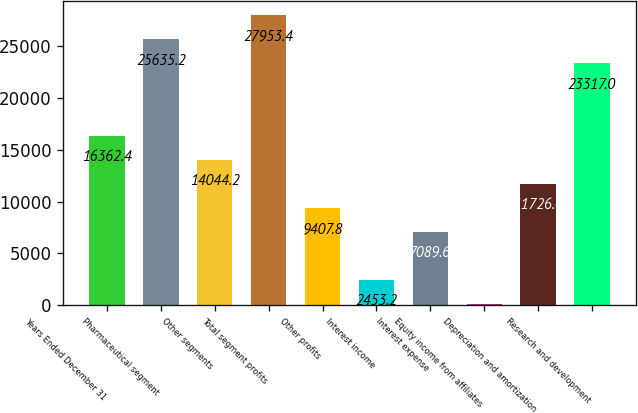Convert chart. <chart><loc_0><loc_0><loc_500><loc_500><bar_chart><fcel>Years Ended December 31<fcel>Pharmaceutical segment<fcel>Other segments<fcel>Total segment profits<fcel>Other profits<fcel>Interest income<fcel>Interest expense<fcel>Equity income from affiliates<fcel>Depreciation and amortization<fcel>Research and development<nl><fcel>16362.4<fcel>25635.2<fcel>14044.2<fcel>27953.4<fcel>9407.8<fcel>2453.2<fcel>7089.6<fcel>135<fcel>11726<fcel>23317<nl></chart> 